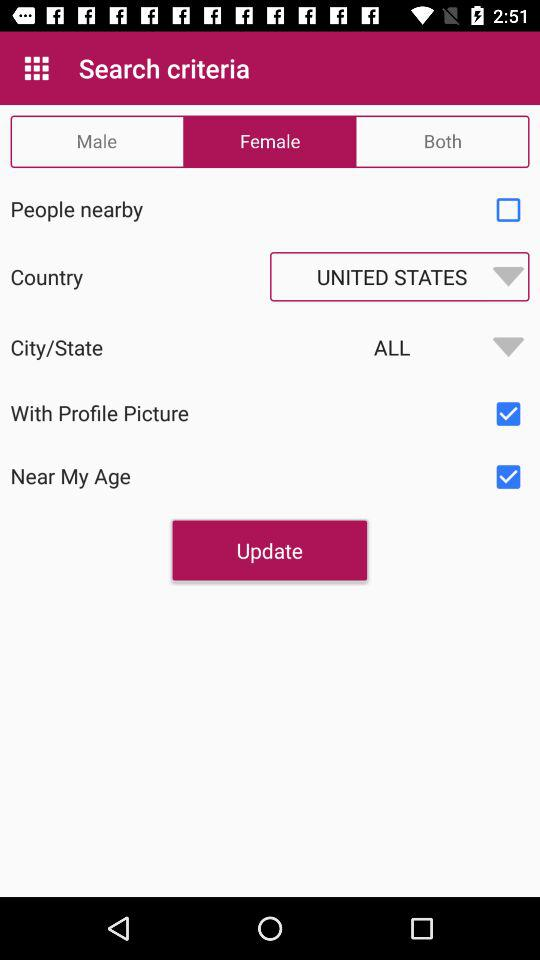What is the status of "Near My Age"? The status is "on". 